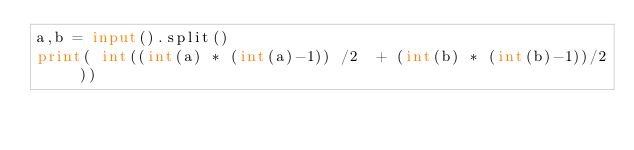<code> <loc_0><loc_0><loc_500><loc_500><_Python_>a,b = input().split()
print( int((int(a) * (int(a)-1)) /2  + (int(b) * (int(b)-1))/2 ))</code> 